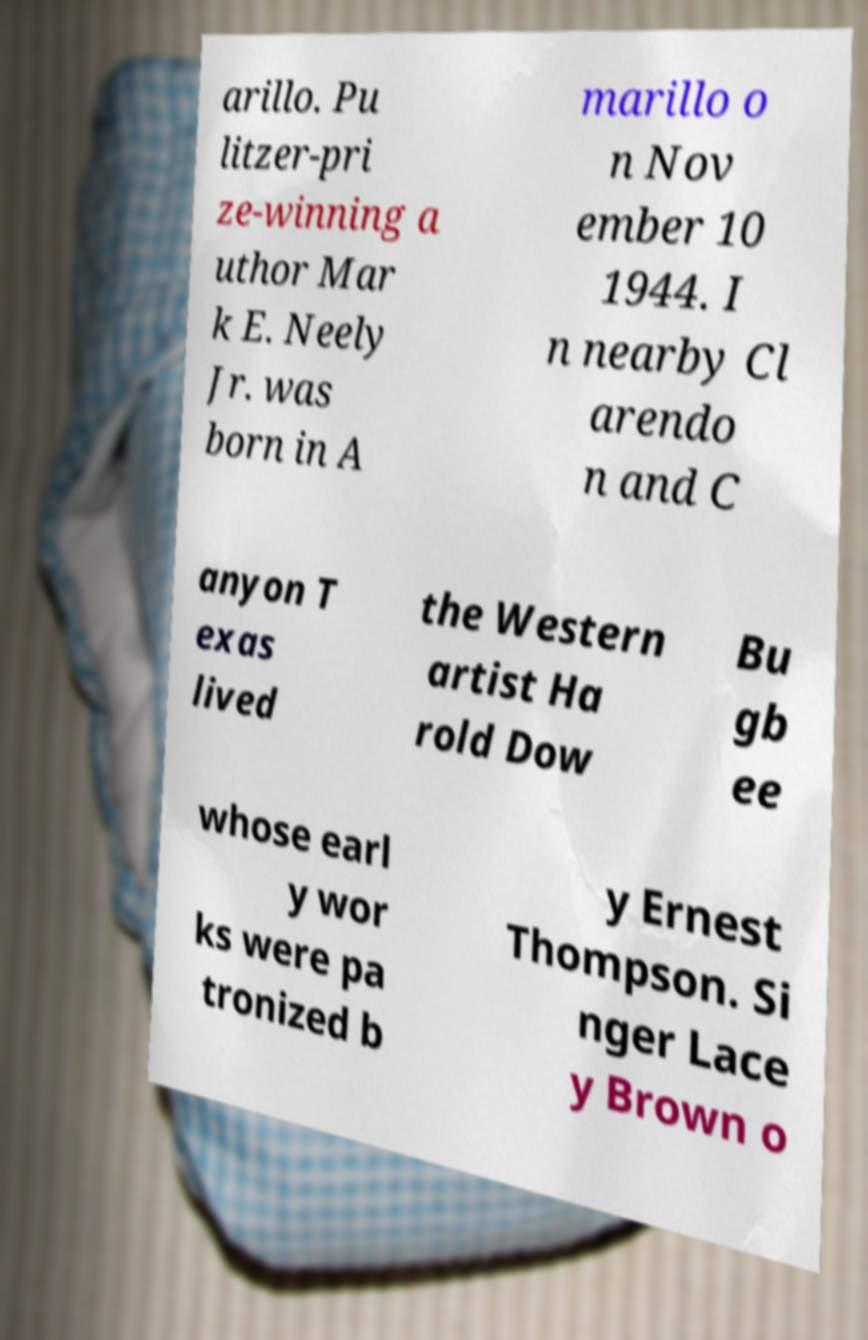Can you read and provide the text displayed in the image?This photo seems to have some interesting text. Can you extract and type it out for me? arillo. Pu litzer-pri ze-winning a uthor Mar k E. Neely Jr. was born in A marillo o n Nov ember 10 1944. I n nearby Cl arendo n and C anyon T exas lived the Western artist Ha rold Dow Bu gb ee whose earl y wor ks were pa tronized b y Ernest Thompson. Si nger Lace y Brown o 